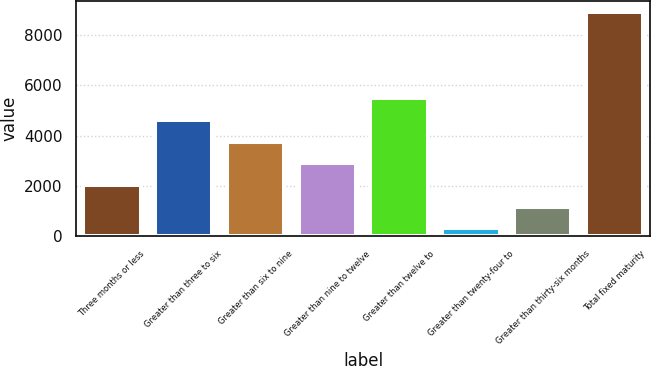Convert chart to OTSL. <chart><loc_0><loc_0><loc_500><loc_500><bar_chart><fcel>Three months or less<fcel>Greater than three to six<fcel>Greater than six to nine<fcel>Greater than nine to twelve<fcel>Greater than twelve to<fcel>Greater than twenty-four to<fcel>Greater than thirty-six months<fcel>Total fixed maturity<nl><fcel>2033.16<fcel>4614.15<fcel>3753.82<fcel>2893.49<fcel>5474.48<fcel>312.5<fcel>1172.83<fcel>8915.8<nl></chart> 